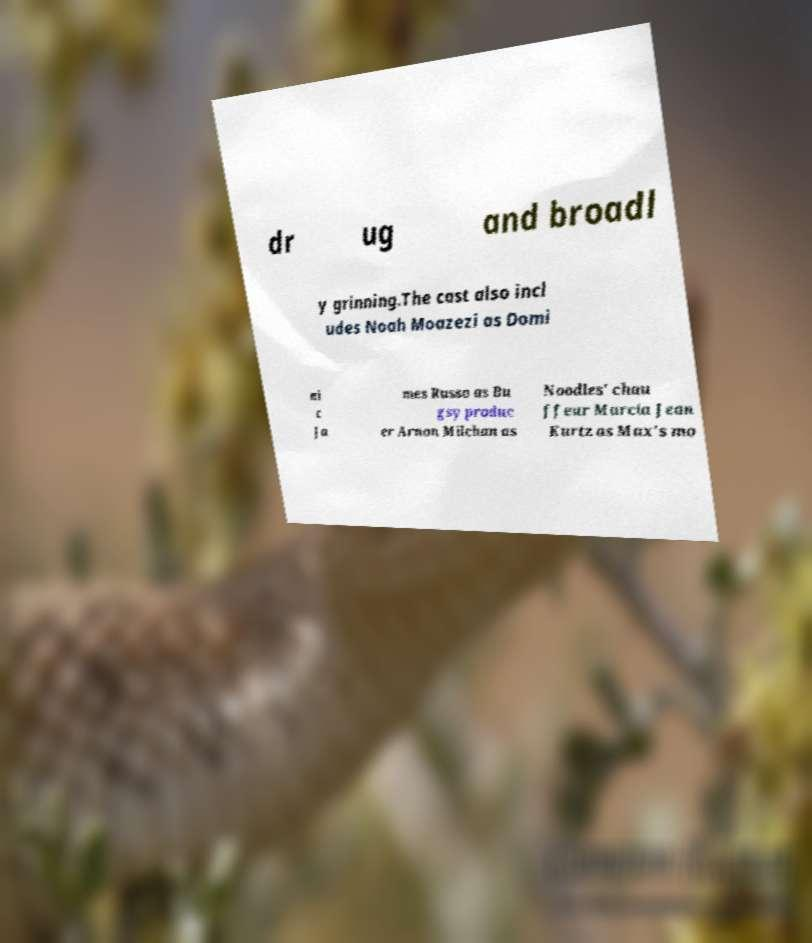Could you extract and type out the text from this image? dr ug and broadl y grinning.The cast also incl udes Noah Moazezi as Domi ni c Ja mes Russo as Bu gsy produc er Arnon Milchan as Noodles' chau ffeur Marcia Jean Kurtz as Max's mo 